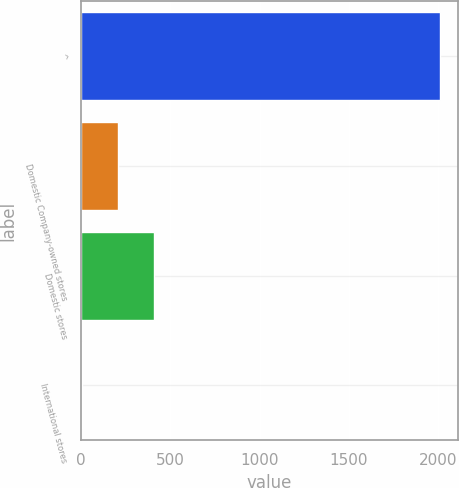<chart> <loc_0><loc_0><loc_500><loc_500><bar_chart><fcel>^<fcel>Domestic Company-owned stores<fcel>Domestic stores<fcel>International stores<nl><fcel>2010<fcel>207.21<fcel>407.52<fcel>6.9<nl></chart> 